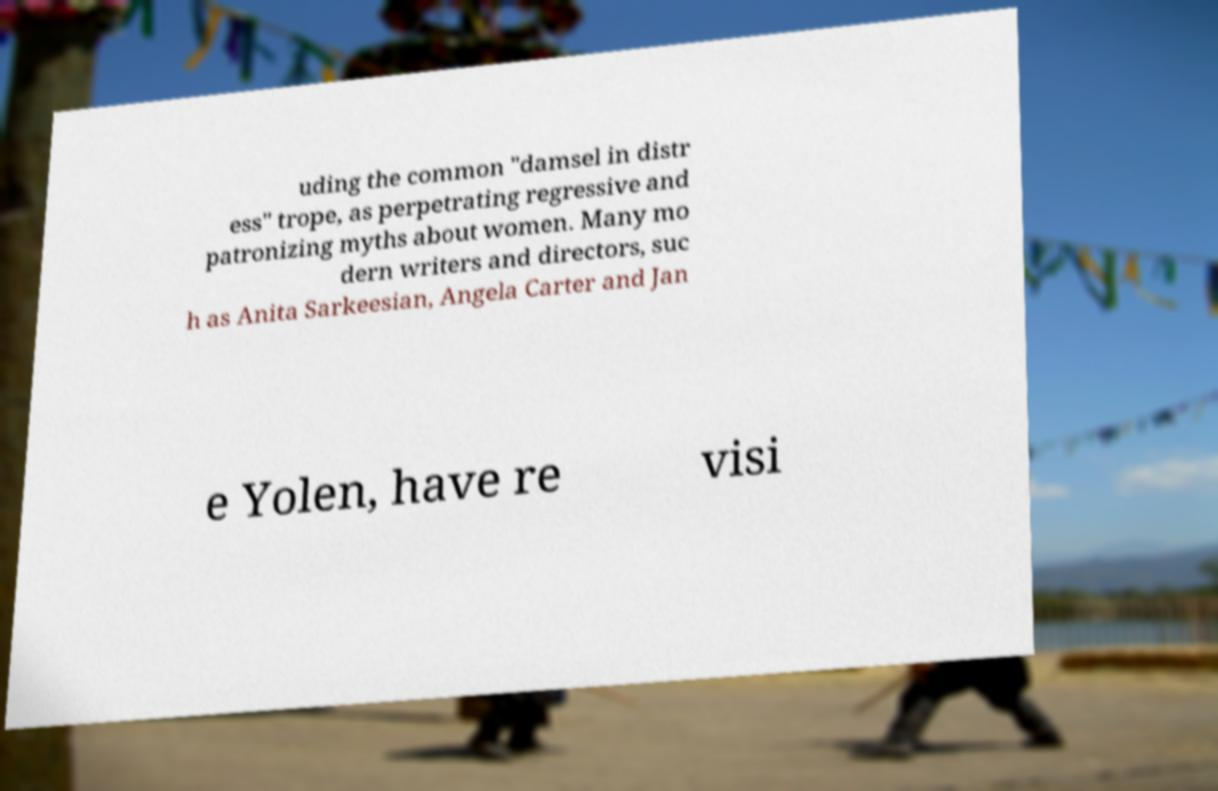Can you accurately transcribe the text from the provided image for me? uding the common "damsel in distr ess" trope, as perpetrating regressive and patronizing myths about women. Many mo dern writers and directors, suc h as Anita Sarkeesian, Angela Carter and Jan e Yolen, have re visi 